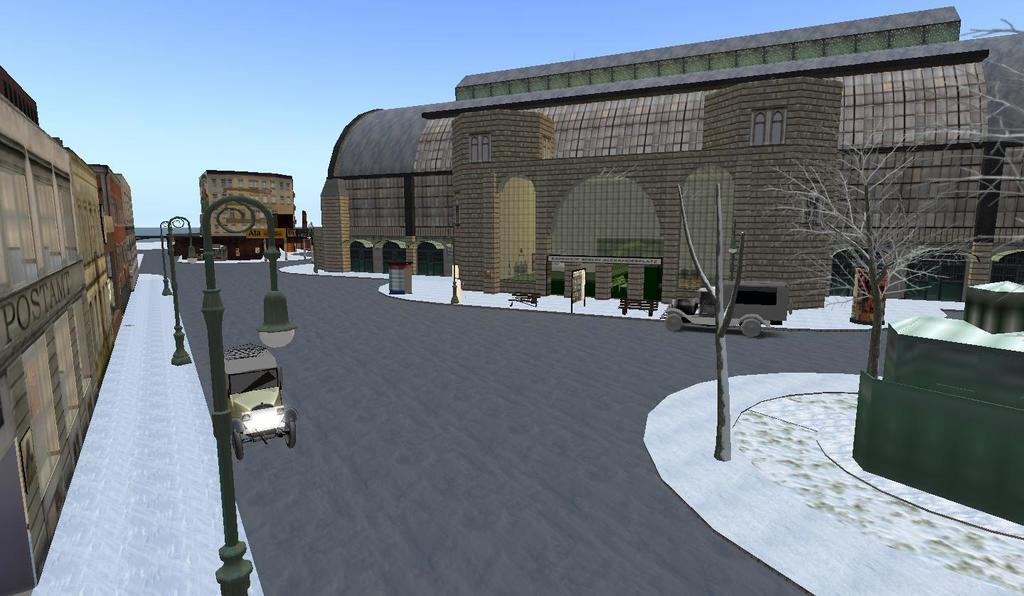What type of image is being described? The image is an animated picture. What structure can be seen in the image? There is a building in the image. What else is present in the image? There is a road and street poles in the image. What part of the natural environment is visible in the image? The sky is visible in the image. Can you see a horse running on the road in the image? There is no horse present in the image; it features an animated picture with a building, road, street poles, and a visible sky. 